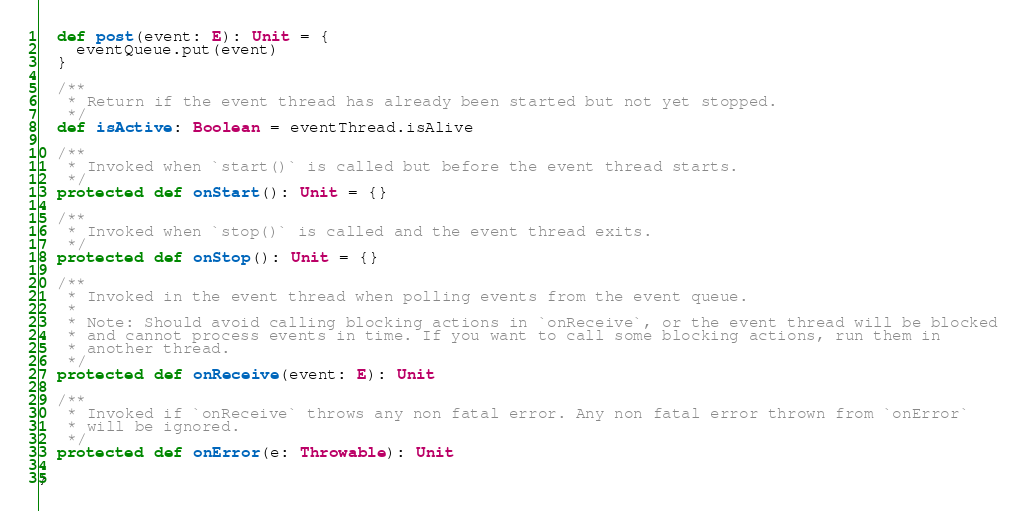<code> <loc_0><loc_0><loc_500><loc_500><_Scala_>  def post(event: E): Unit = {
    eventQueue.put(event)
  }

  /**
   * Return if the event thread has already been started but not yet stopped.
   */
  def isActive: Boolean = eventThread.isAlive

  /**
   * Invoked when `start()` is called but before the event thread starts.
   */
  protected def onStart(): Unit = {}

  /**
   * Invoked when `stop()` is called and the event thread exits.
   */
  protected def onStop(): Unit = {}

  /**
   * Invoked in the event thread when polling events from the event queue.
   *
   * Note: Should avoid calling blocking actions in `onReceive`, or the event thread will be blocked
   * and cannot process events in time. If you want to call some blocking actions, run them in
   * another thread.
   */
  protected def onReceive(event: E): Unit

  /**
   * Invoked if `onReceive` throws any non fatal error. Any non fatal error thrown from `onError`
   * will be ignored.
   */
  protected def onError(e: Throwable): Unit

}
</code> 